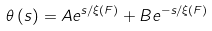<formula> <loc_0><loc_0><loc_500><loc_500>\theta \left ( s \right ) = A e ^ { s / \xi \left ( F \right ) } + B e ^ { - s / \xi \left ( F \right ) }</formula> 